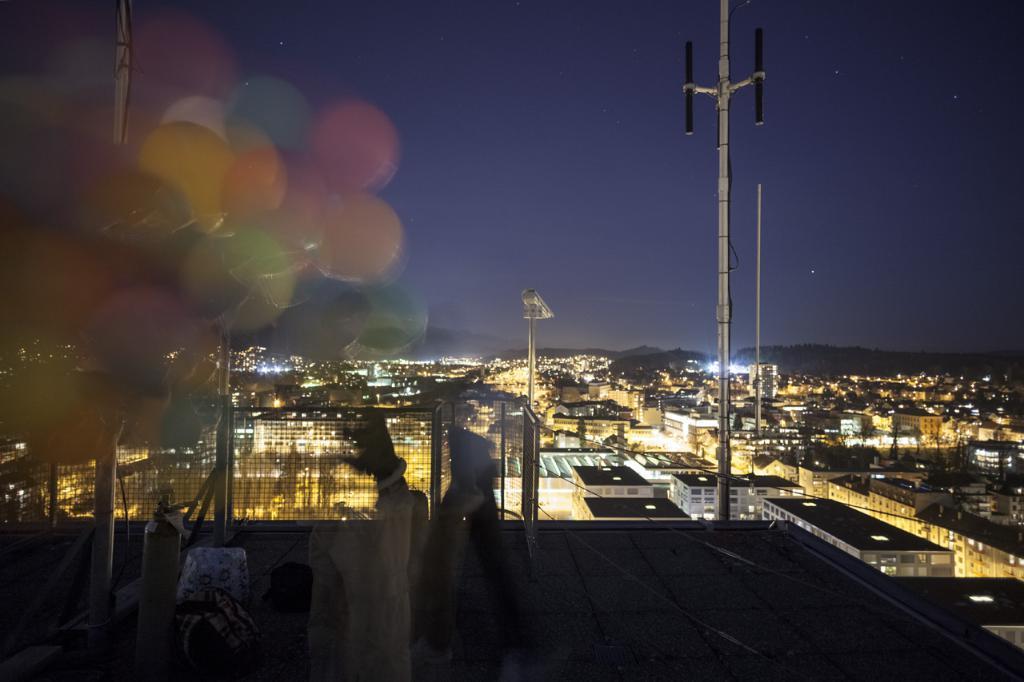How would you summarize this image in a sentence or two? In this image I can see few multi color balloons, background I can see few poles, buildings and I can see few multi color lights and the sky is in blue and black color. 